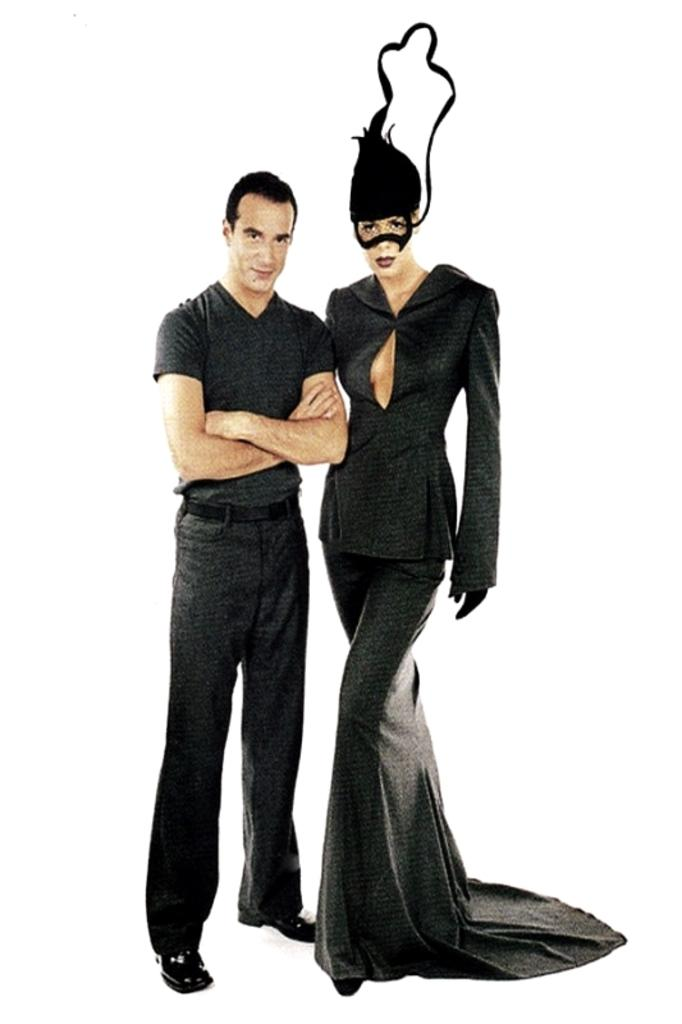How many people are in the image? There are two persons in the image. What color are the dresses worn by the persons in the image? Both persons are wearing black color dresses. What is the color of the background in the image? The background of the image is white. What type of shoes can be seen on the persons in the image? There is no information about shoes in the image, as the provided facts only mention the color of the dresses and the color of the background. 